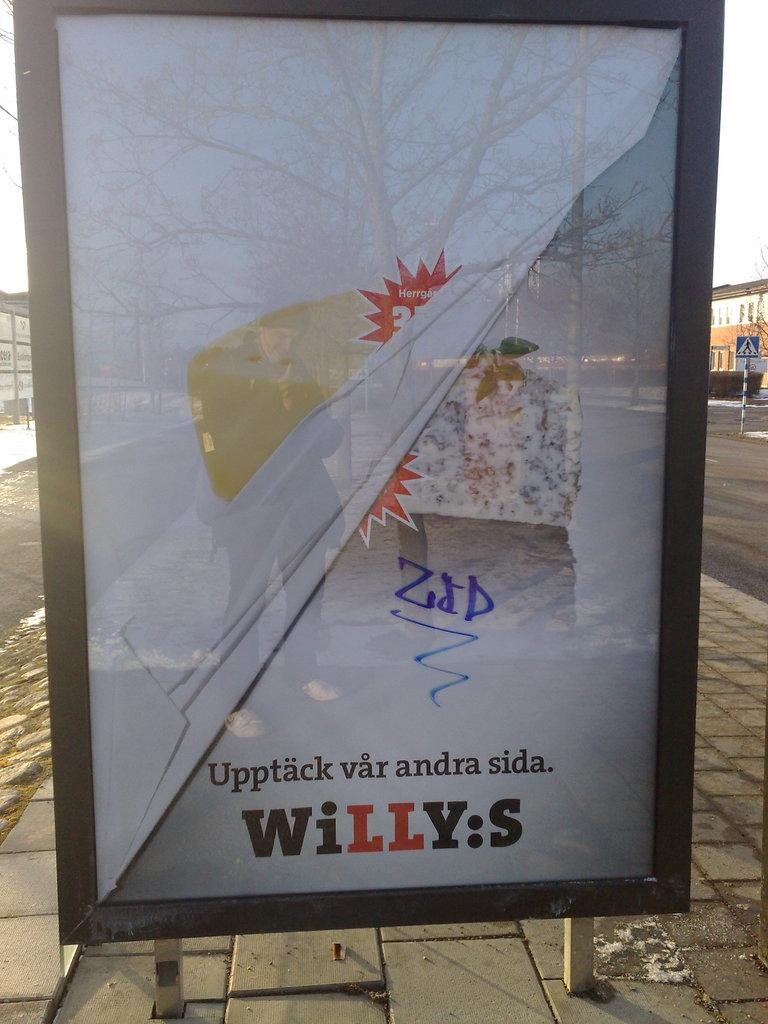<image>
Render a clear and concise summary of the photo. an ads boards saying Upptack var andra sida 